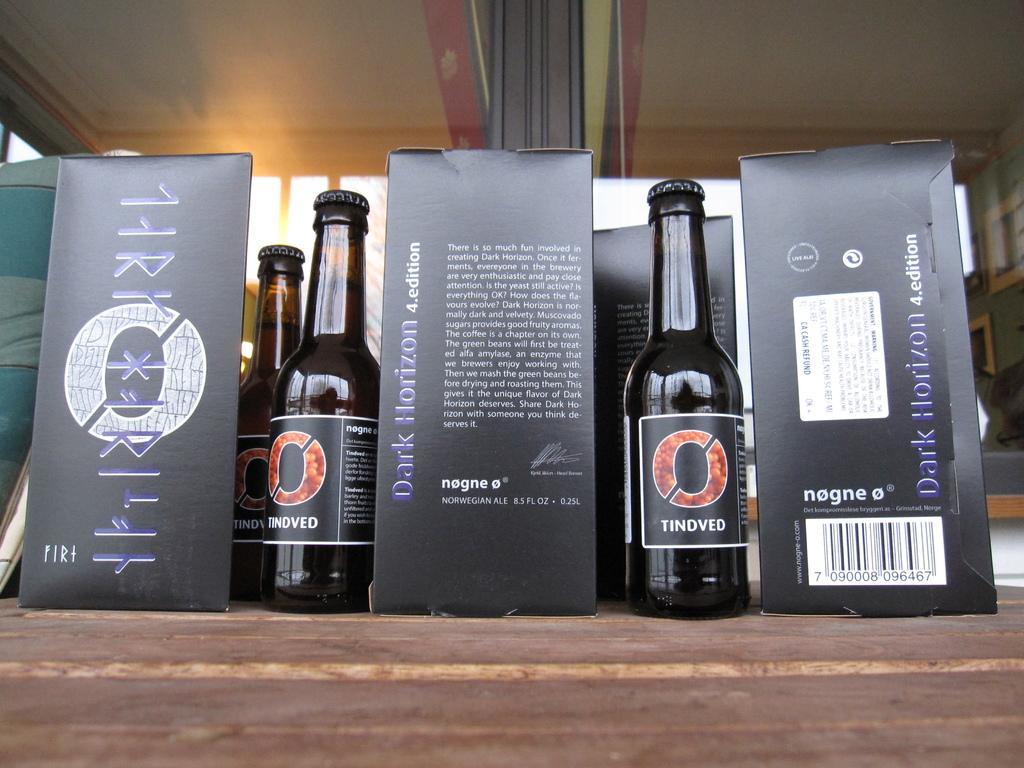What does it say on the beer bottles?
Offer a very short reply. Tindved. 